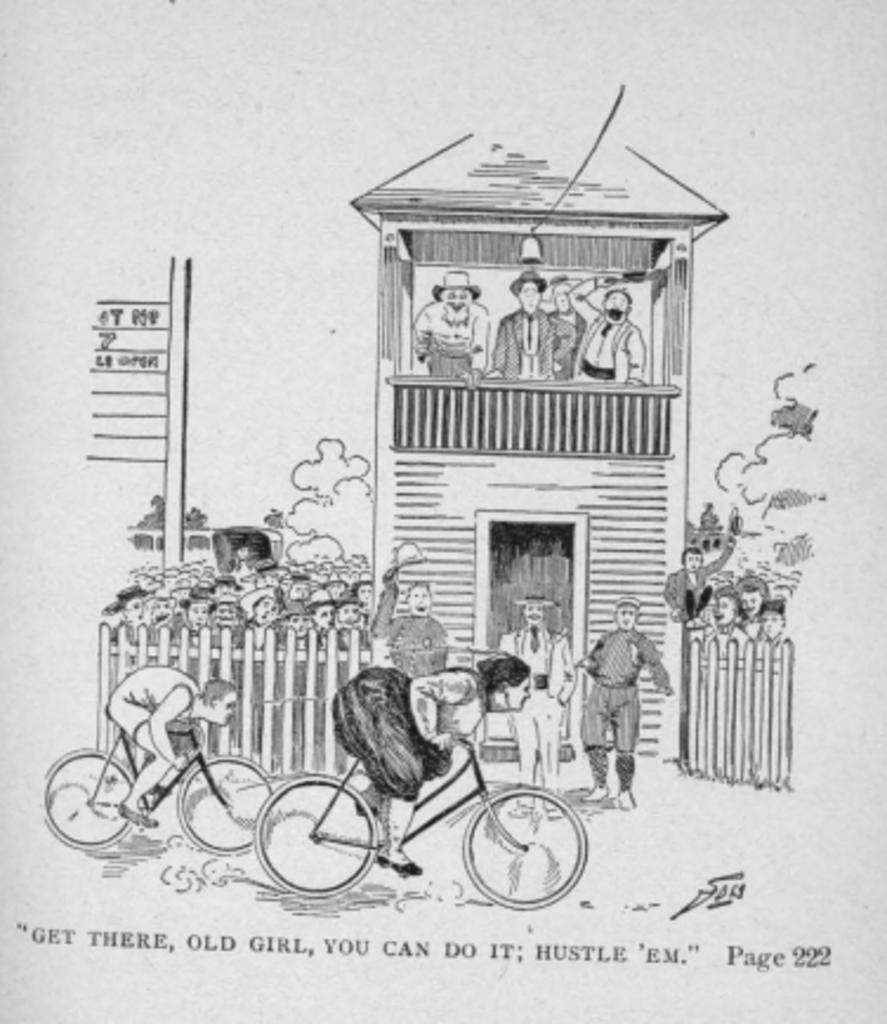What is the main subject of the image? The image is of a paper. What is depicted on the paper? There is a drawing of a house on the paper. Are there any other elements in the drawing besides the house? Yes, there are people in the drawing. What can be found at the bottom of the paper? There is writing at the bottom of the paper. Can you see a snail with a wing in the drawing? There is no snail with a wing present in the drawing; it only features a house and people. 